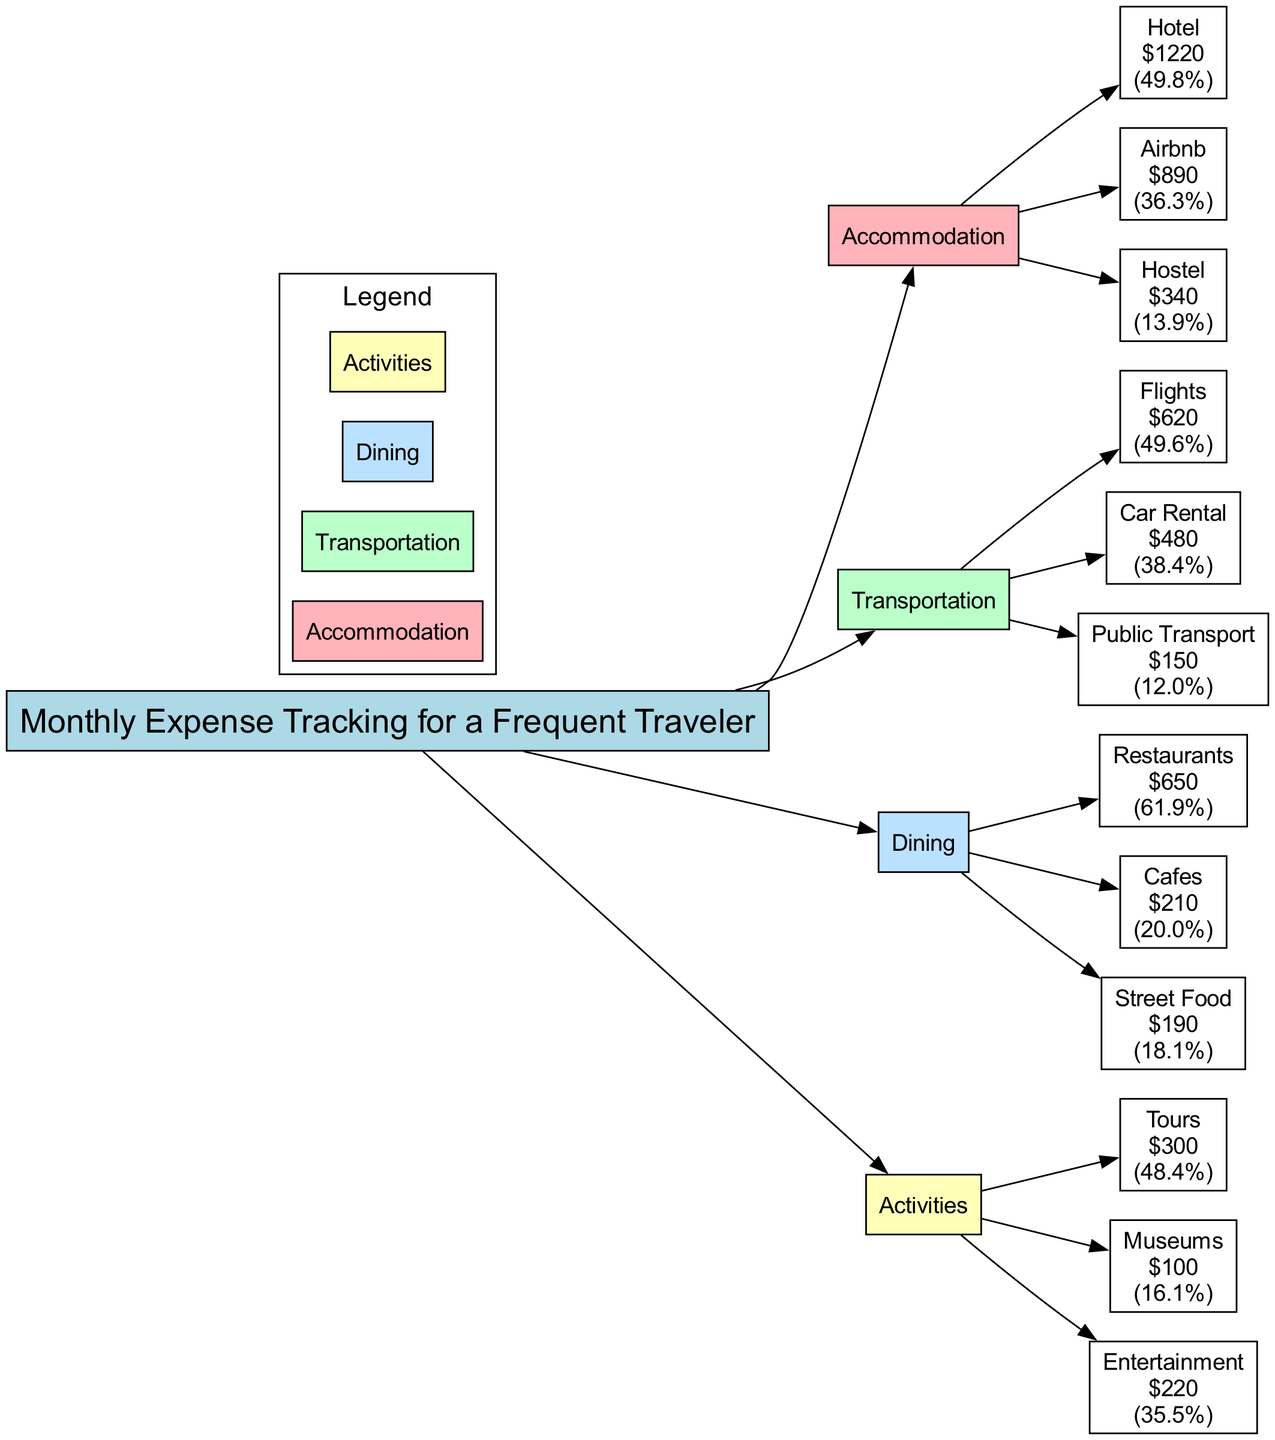What is the total expense for Accommodation? To find the total expense for Accommodation, we sum the values of its subcategories: Hotel (1220) + Airbnb (890) + Hostel (340) = 2200.
Answer: 2200 What is the value for Public Transport? The value for Public Transport is directly provided in the diagram. It is listed under Transportation as 150.
Answer: 150 Which category has the highest total expenses? To determine which category has the highest total expenses, we need to calculate the totals for each category: Accommodation (2200), Transportation (1250), Dining (1050), Activities (620). Accommodation has the highest total at 2200.
Answer: Accommodation How much was spent on Tours? The amount spent on Tours is directly indicated in the diagram under Activities as 300.
Answer: 300 What percentage of total Dining expenses was spent on Restaurants? The total Dining expenses are calculated as Restaurants (650) + Cafes (210) + Street Food (190) = 1050. The percentage spent on Restaurants is (650 / 1050) * 100, which equals approximately 61.9%.
Answer: 61.9% Which type of accommodation had the least expense? By reviewing the accommodation subcategories, we see their values: Hotel (1220), Airbnb (890), and Hostel (340). The lowest value is from Hostel at 340.
Answer: Hostel What is the combined expense for Activities? The combined expense for activities can be determined by summing the values of Tours (300), Museums (100), and Entertainment (220): 300 + 100 + 220 = 620.
Answer: 620 Which dining option had the highest expense? The dining options and their expenses are: Restaurants (650), Cafes (210), and Street Food (190). The one with the highest expense is Restaurants at 650.
Answer: Restaurants What is the total Transportation expense? To calculate the total Transportation expense, we sum its subcategories: Flights (620), Car Rental (480), and Public Transport (150), resulting in 620 + 480 + 150 = 1250.
Answer: 1250 